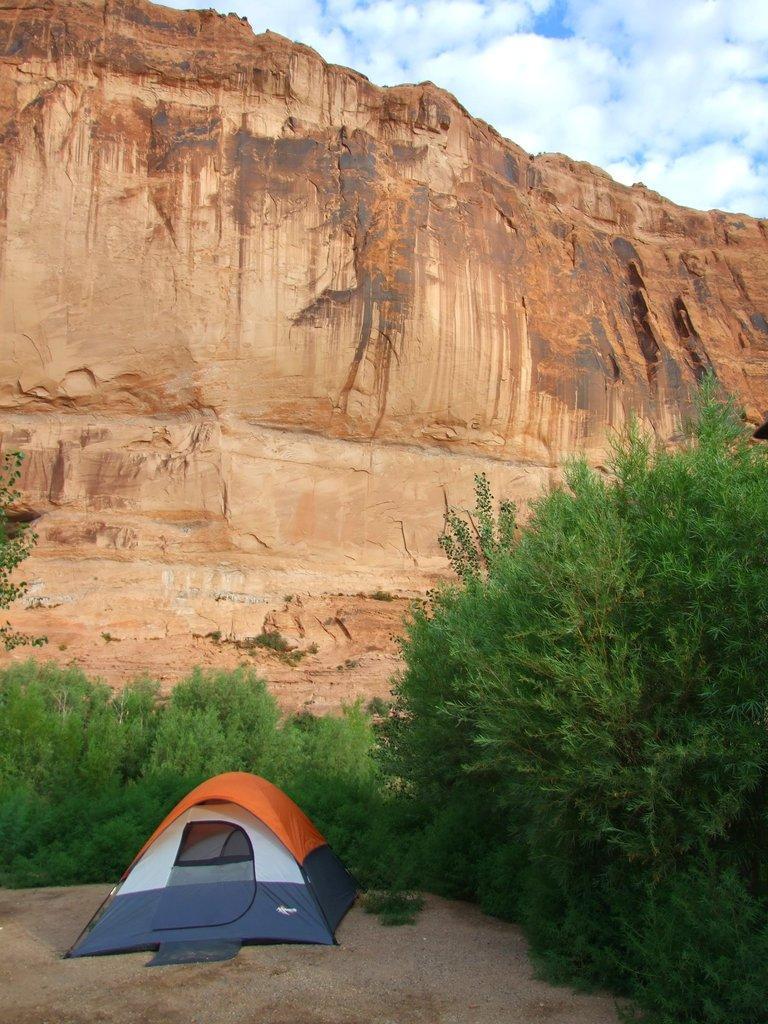Could you give a brief overview of what you see in this image? In this image I can see a tent. I can see the trees. In the background, I can see the hills and clouds in the sky. 